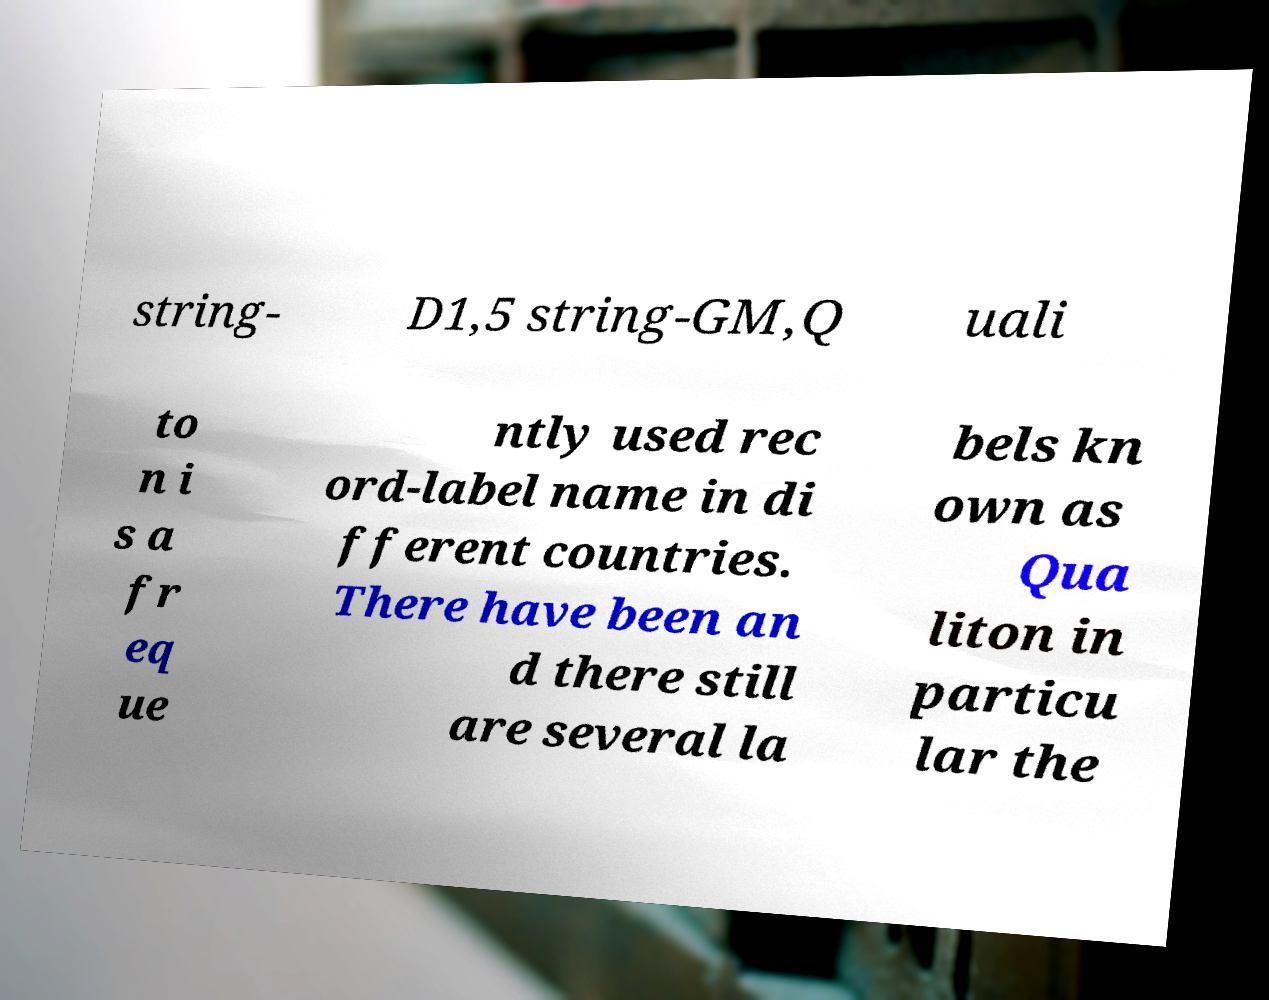Can you read and provide the text displayed in the image?This photo seems to have some interesting text. Can you extract and type it out for me? string- D1,5 string-GM,Q uali to n i s a fr eq ue ntly used rec ord-label name in di fferent countries. There have been an d there still are several la bels kn own as Qua liton in particu lar the 